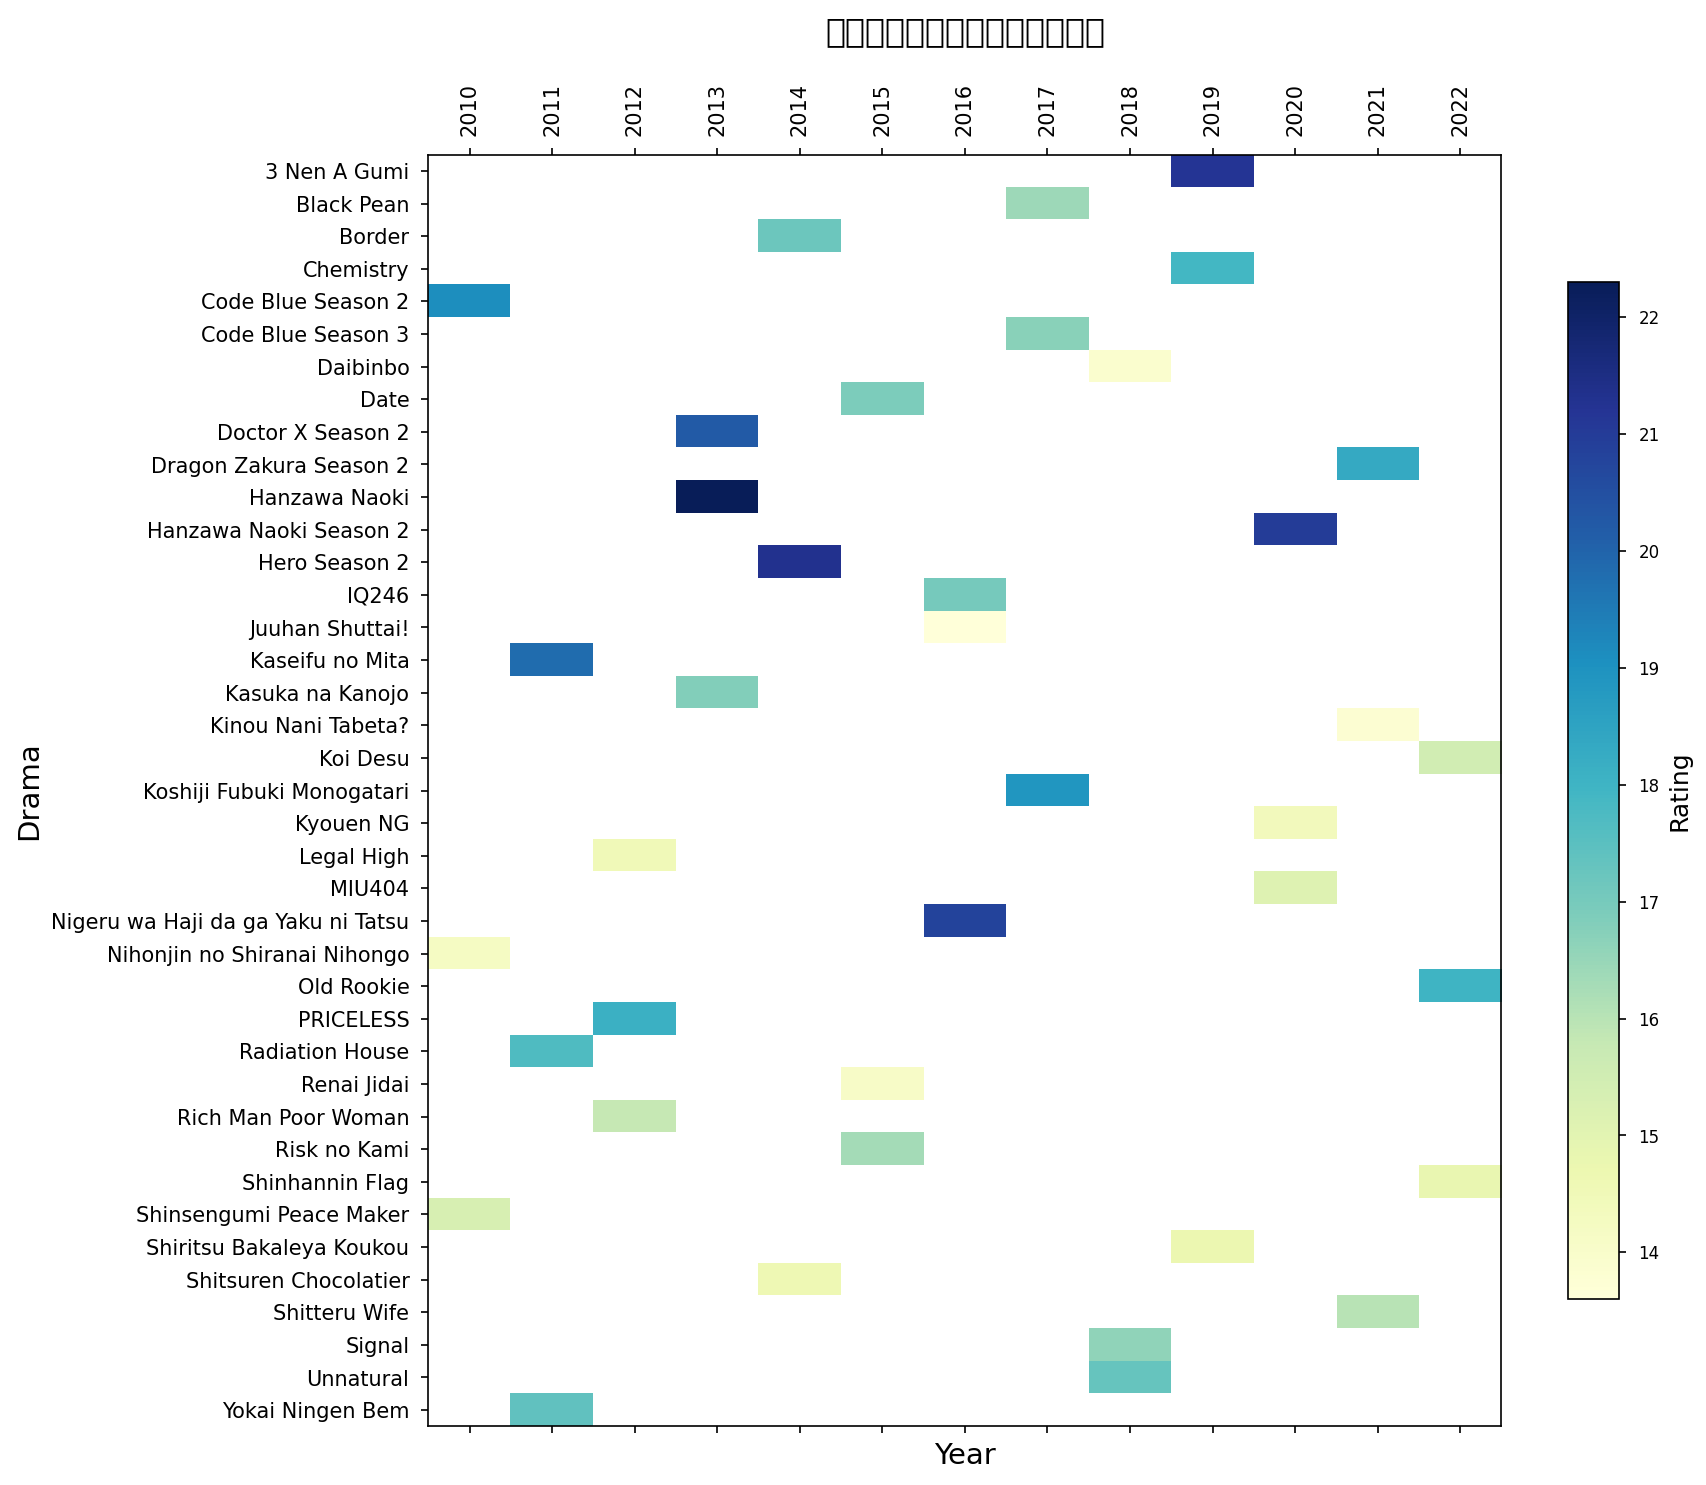哪个年份的日剧收视率最高? 要回答这个问题，我们需要查看每一个年份的收视率，并找到最高值。在热图上查找所有的年份，找到表示收视率最高的一格即可。
Answer: 2013 日剧《Hanzawa Naoki》在其首播年和续播年的收视率是多少? 查看热图中《Hanzawa Naoki》在不同年份的收视率分布。找到2013年和2020年的相应单元格来获得各年份的收视率。
Answer: 22.3 和 21.0 2016年和2020年哪一年的平均收视率更高？ 我们需要计算2016年和2020年的日剧收视率的平均值。在热图中找到这些年份的所有日剧收视率，然后分别求取它们的平均值，最终比较两个平均值。2016年均值计算：(20.8+13.6+17.0)/3，2020年均值：(15.1+21.0+14.4)/3
Answer: 2016 收视率最低的日剧是哪一部？ 查看热图中所有表示收视率的单元格，并找到颜色最浅的单元格对应的日剧，它代表了最低的收视率。
Answer: 《Juuhan Shuttai!》 《Code Blue》系列的收视率在不同年份有何变化? 在热图中查找《Code Blue》系列的各个单元格，分别查看每个年份的收视情况，并比较各年间的差异。2010年《Code Blue Season 2》为 19.1，2017年《Code Blue Season 3》为 16.7。
Answer: 下降 哪个年份的日剧整体表现更好：2014年还是2018年？ 我们需要查看2014年和2018年每部日剧的收视率，并计算每一年的平均值来比较整体表现。2014年平均值：(21.3+14.6+17.2)/3，2018年平均值：(17.3+16.6+13.9)/3
Answer: 2014 2012年的哪部日剧收视率最高？ 查看热图中2012年这一列的各个单元格，并找到颜色最深的单元格，它对应的就是收视率最高的日剧。
Answer: 《PRICELESS》 收视率超过18的日剧有哪些？ 在热图中查找颜色较深（表示高收视率）的单元格。逐一确认这些日剧的名称，确保它们的收视率确实超过了18。
Answer: 《Hanzawa Naoki》《Doctor X Season 2》《Hero Season 2》《Nigeru wa Haji da ga Yaku ni Tatsu》《Kaseifu no Mita》《3 Nen A Gumi》《Old Rookie》《Radiation House》《Code Blue Season 2》 《Rich Man Poor Woman》的收视率在哪一年中最好？ 查找热图中《Rich Man Poor Woman》的单元格，并根据年份即可知道该剧的收视年份。
Answer: 2012年 